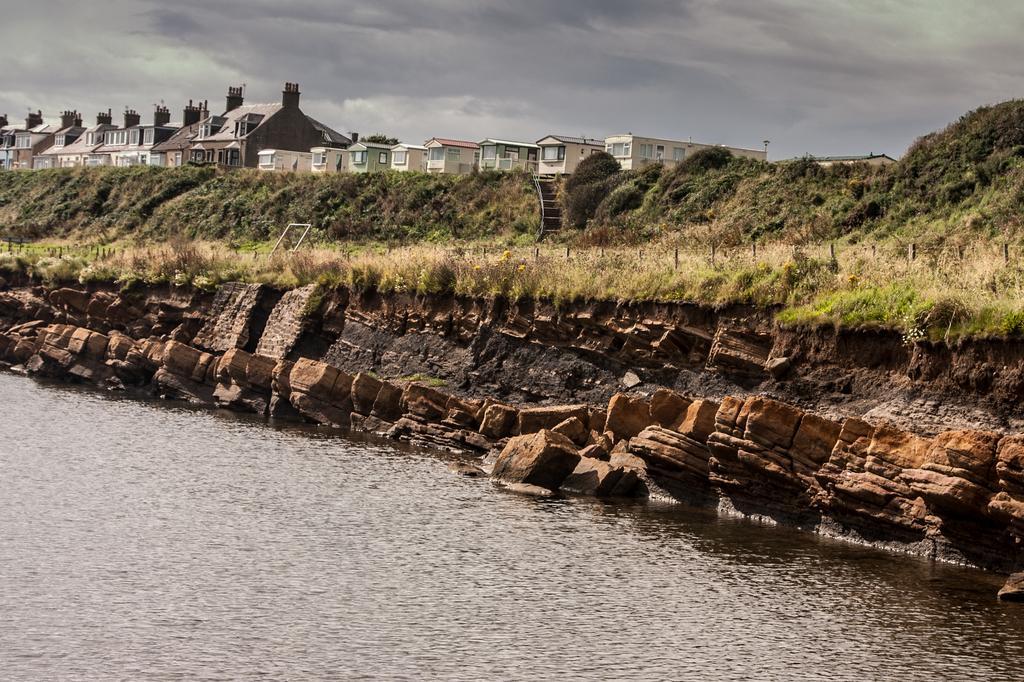Describe this image in one or two sentences. In this image at the bottom there is a river, and in the center there is grass and some rocks and rods. And in the background there are some trees, buildings, at the top there is sky. 